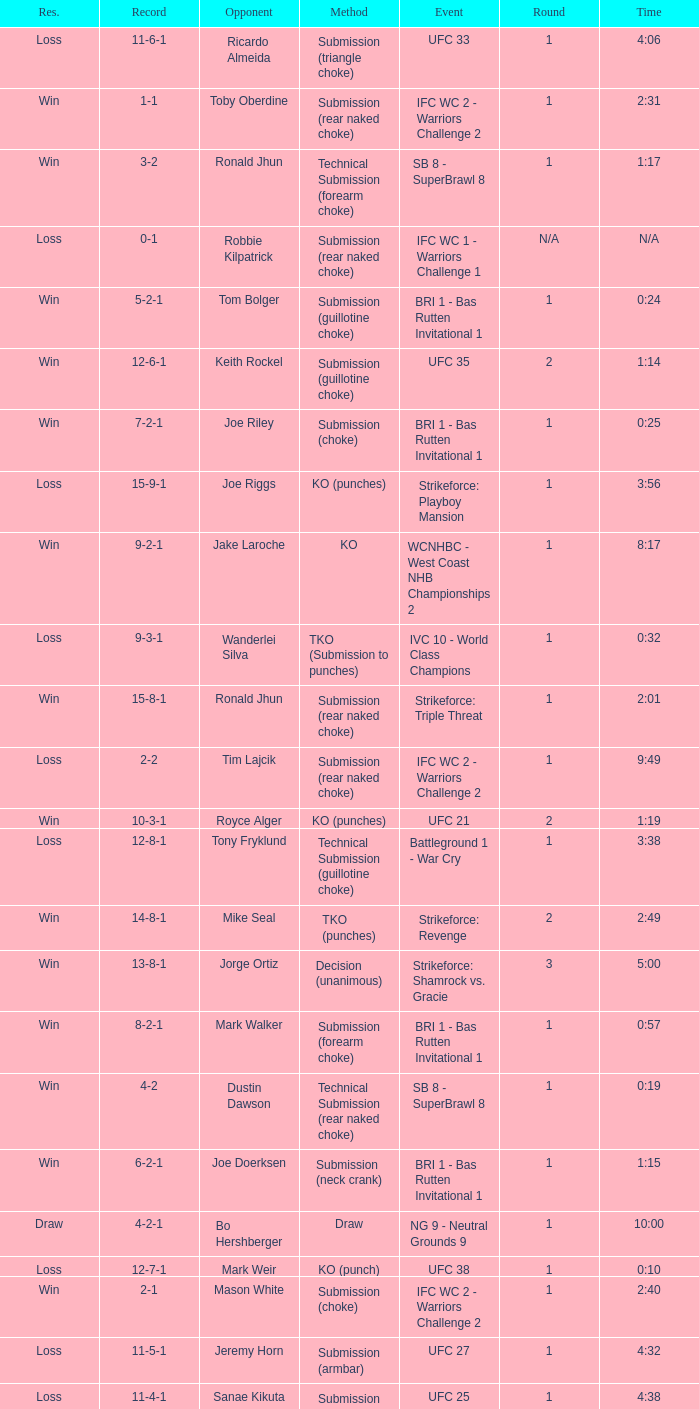Can you parse all the data within this table? {'header': ['Res.', 'Record', 'Opponent', 'Method', 'Event', 'Round', 'Time'], 'rows': [['Loss', '11-6-1', 'Ricardo Almeida', 'Submission (triangle choke)', 'UFC 33', '1', '4:06'], ['Win', '1-1', 'Toby Oberdine', 'Submission (rear naked choke)', 'IFC WC 2 - Warriors Challenge 2', '1', '2:31'], ['Win', '3-2', 'Ronald Jhun', 'Technical Submission (forearm choke)', 'SB 8 - SuperBrawl 8', '1', '1:17'], ['Loss', '0-1', 'Robbie Kilpatrick', 'Submission (rear naked choke)', 'IFC WC 1 - Warriors Challenge 1', 'N/A', 'N/A'], ['Win', '5-2-1', 'Tom Bolger', 'Submission (guillotine choke)', 'BRI 1 - Bas Rutten Invitational 1', '1', '0:24'], ['Win', '12-6-1', 'Keith Rockel', 'Submission (guillotine choke)', 'UFC 35', '2', '1:14'], ['Win', '7-2-1', 'Joe Riley', 'Submission (choke)', 'BRI 1 - Bas Rutten Invitational 1', '1', '0:25'], ['Loss', '15-9-1', 'Joe Riggs', 'KO (punches)', 'Strikeforce: Playboy Mansion', '1', '3:56'], ['Win', '9-2-1', 'Jake Laroche', 'KO', 'WCNHBC - West Coast NHB Championships 2', '1', '8:17'], ['Loss', '9-3-1', 'Wanderlei Silva', 'TKO (Submission to punches)', 'IVC 10 - World Class Champions', '1', '0:32'], ['Win', '15-8-1', 'Ronald Jhun', 'Submission (rear naked choke)', 'Strikeforce: Triple Threat', '1', '2:01'], ['Loss', '2-2', 'Tim Lajcik', 'Submission (rear naked choke)', 'IFC WC 2 - Warriors Challenge 2', '1', '9:49'], ['Win', '10-3-1', 'Royce Alger', 'KO (punches)', 'UFC 21', '2', '1:19'], ['Loss', '12-8-1', 'Tony Fryklund', 'Technical Submission (guillotine choke)', 'Battleground 1 - War Cry', '1', '3:38'], ['Win', '14-8-1', 'Mike Seal', 'TKO (punches)', 'Strikeforce: Revenge', '2', '2:49'], ['Win', '13-8-1', 'Jorge Ortiz', 'Decision (unanimous)', 'Strikeforce: Shamrock vs. Gracie', '3', '5:00'], ['Win', '8-2-1', 'Mark Walker', 'Submission (forearm choke)', 'BRI 1 - Bas Rutten Invitational 1', '1', '0:57'], ['Win', '4-2', 'Dustin Dawson', 'Technical Submission (rear naked choke)', 'SB 8 - SuperBrawl 8', '1', '0:19'], ['Win', '6-2-1', 'Joe Doerksen', 'Submission (neck crank)', 'BRI 1 - Bas Rutten Invitational 1', '1', '1:15'], ['Draw', '4-2-1', 'Bo Hershberger', 'Draw', 'NG 9 - Neutral Grounds 9', '1', '10:00'], ['Loss', '12-7-1', 'Mark Weir', 'KO (punch)', 'UFC 38', '1', '0:10'], ['Win', '2-1', 'Mason White', 'Submission (choke)', 'IFC WC 2 - Warriors Challenge 2', '1', '2:40'], ['Loss', '11-5-1', 'Jeremy Horn', 'Submission (armbar)', 'UFC 27', '1', '4:32'], ['Loss', '11-4-1', 'Sanae Kikuta', 'Submission (armbar)', 'UFC 25', '1', '4:38'], ['Win', '11-3-1', 'Keiichiro Yamamiya', 'KO (punch)', 'UFC 23', '3', '3:12']]} What is the record when the fight was against keith rockel? 12-6-1. 